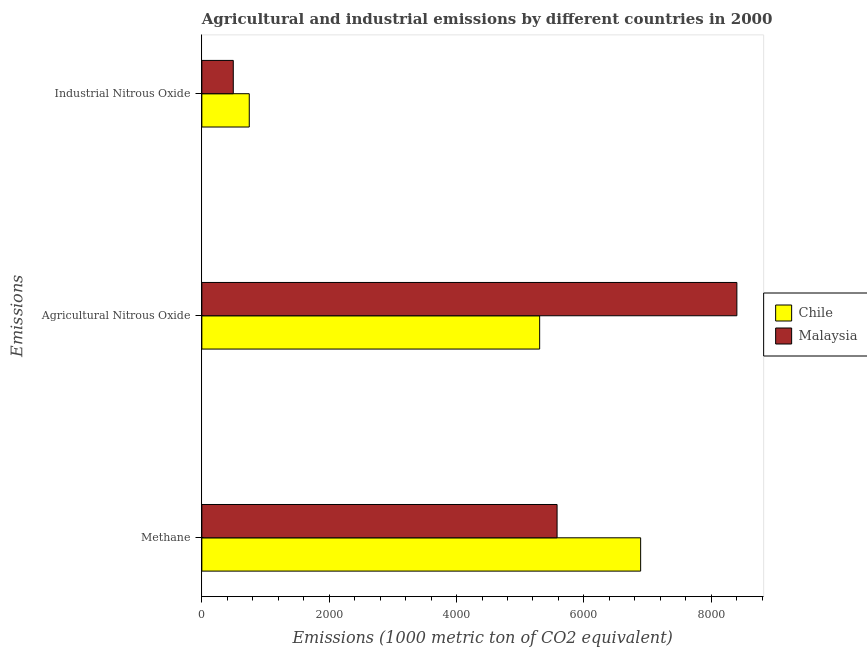How many different coloured bars are there?
Provide a short and direct response. 2. How many groups of bars are there?
Your answer should be compact. 3. How many bars are there on the 2nd tick from the bottom?
Offer a very short reply. 2. What is the label of the 3rd group of bars from the top?
Keep it short and to the point. Methane. What is the amount of methane emissions in Chile?
Your answer should be compact. 6891.6. Across all countries, what is the maximum amount of agricultural nitrous oxide emissions?
Your answer should be very brief. 8403.2. Across all countries, what is the minimum amount of industrial nitrous oxide emissions?
Offer a very short reply. 493.8. In which country was the amount of methane emissions minimum?
Offer a very short reply. Malaysia. What is the total amount of agricultural nitrous oxide emissions in the graph?
Give a very brief answer. 1.37e+04. What is the difference between the amount of methane emissions in Malaysia and that in Chile?
Your response must be concise. -1312.4. What is the difference between the amount of industrial nitrous oxide emissions in Malaysia and the amount of methane emissions in Chile?
Provide a succinct answer. -6397.8. What is the average amount of methane emissions per country?
Provide a short and direct response. 6235.4. What is the difference between the amount of methane emissions and amount of industrial nitrous oxide emissions in Malaysia?
Your answer should be compact. 5085.4. What is the ratio of the amount of industrial nitrous oxide emissions in Malaysia to that in Chile?
Give a very brief answer. 0.66. Is the amount of industrial nitrous oxide emissions in Malaysia less than that in Chile?
Offer a very short reply. Yes. What is the difference between the highest and the second highest amount of methane emissions?
Make the answer very short. 1312.4. What is the difference between the highest and the lowest amount of industrial nitrous oxide emissions?
Offer a very short reply. 251.1. What does the 1st bar from the top in Industrial Nitrous Oxide represents?
Offer a terse response. Malaysia. What does the 2nd bar from the bottom in Methane represents?
Provide a short and direct response. Malaysia. How many countries are there in the graph?
Make the answer very short. 2. What is the difference between two consecutive major ticks on the X-axis?
Your answer should be very brief. 2000. Does the graph contain any zero values?
Ensure brevity in your answer.  No. Where does the legend appear in the graph?
Your response must be concise. Center right. How many legend labels are there?
Ensure brevity in your answer.  2. What is the title of the graph?
Make the answer very short. Agricultural and industrial emissions by different countries in 2000. What is the label or title of the X-axis?
Make the answer very short. Emissions (1000 metric ton of CO2 equivalent). What is the label or title of the Y-axis?
Ensure brevity in your answer.  Emissions. What is the Emissions (1000 metric ton of CO2 equivalent) of Chile in Methane?
Your answer should be very brief. 6891.6. What is the Emissions (1000 metric ton of CO2 equivalent) of Malaysia in Methane?
Ensure brevity in your answer.  5579.2. What is the Emissions (1000 metric ton of CO2 equivalent) of Chile in Agricultural Nitrous Oxide?
Your answer should be very brief. 5305.7. What is the Emissions (1000 metric ton of CO2 equivalent) of Malaysia in Agricultural Nitrous Oxide?
Give a very brief answer. 8403.2. What is the Emissions (1000 metric ton of CO2 equivalent) in Chile in Industrial Nitrous Oxide?
Give a very brief answer. 744.9. What is the Emissions (1000 metric ton of CO2 equivalent) of Malaysia in Industrial Nitrous Oxide?
Keep it short and to the point. 493.8. Across all Emissions, what is the maximum Emissions (1000 metric ton of CO2 equivalent) in Chile?
Keep it short and to the point. 6891.6. Across all Emissions, what is the maximum Emissions (1000 metric ton of CO2 equivalent) in Malaysia?
Offer a terse response. 8403.2. Across all Emissions, what is the minimum Emissions (1000 metric ton of CO2 equivalent) of Chile?
Give a very brief answer. 744.9. Across all Emissions, what is the minimum Emissions (1000 metric ton of CO2 equivalent) in Malaysia?
Your response must be concise. 493.8. What is the total Emissions (1000 metric ton of CO2 equivalent) in Chile in the graph?
Give a very brief answer. 1.29e+04. What is the total Emissions (1000 metric ton of CO2 equivalent) of Malaysia in the graph?
Provide a succinct answer. 1.45e+04. What is the difference between the Emissions (1000 metric ton of CO2 equivalent) in Chile in Methane and that in Agricultural Nitrous Oxide?
Provide a succinct answer. 1585.9. What is the difference between the Emissions (1000 metric ton of CO2 equivalent) of Malaysia in Methane and that in Agricultural Nitrous Oxide?
Offer a very short reply. -2824. What is the difference between the Emissions (1000 metric ton of CO2 equivalent) in Chile in Methane and that in Industrial Nitrous Oxide?
Provide a short and direct response. 6146.7. What is the difference between the Emissions (1000 metric ton of CO2 equivalent) in Malaysia in Methane and that in Industrial Nitrous Oxide?
Your answer should be very brief. 5085.4. What is the difference between the Emissions (1000 metric ton of CO2 equivalent) of Chile in Agricultural Nitrous Oxide and that in Industrial Nitrous Oxide?
Offer a very short reply. 4560.8. What is the difference between the Emissions (1000 metric ton of CO2 equivalent) of Malaysia in Agricultural Nitrous Oxide and that in Industrial Nitrous Oxide?
Your answer should be compact. 7909.4. What is the difference between the Emissions (1000 metric ton of CO2 equivalent) of Chile in Methane and the Emissions (1000 metric ton of CO2 equivalent) of Malaysia in Agricultural Nitrous Oxide?
Ensure brevity in your answer.  -1511.6. What is the difference between the Emissions (1000 metric ton of CO2 equivalent) of Chile in Methane and the Emissions (1000 metric ton of CO2 equivalent) of Malaysia in Industrial Nitrous Oxide?
Your answer should be very brief. 6397.8. What is the difference between the Emissions (1000 metric ton of CO2 equivalent) in Chile in Agricultural Nitrous Oxide and the Emissions (1000 metric ton of CO2 equivalent) in Malaysia in Industrial Nitrous Oxide?
Keep it short and to the point. 4811.9. What is the average Emissions (1000 metric ton of CO2 equivalent) in Chile per Emissions?
Provide a succinct answer. 4314.07. What is the average Emissions (1000 metric ton of CO2 equivalent) in Malaysia per Emissions?
Keep it short and to the point. 4825.4. What is the difference between the Emissions (1000 metric ton of CO2 equivalent) in Chile and Emissions (1000 metric ton of CO2 equivalent) in Malaysia in Methane?
Your response must be concise. 1312.4. What is the difference between the Emissions (1000 metric ton of CO2 equivalent) in Chile and Emissions (1000 metric ton of CO2 equivalent) in Malaysia in Agricultural Nitrous Oxide?
Offer a very short reply. -3097.5. What is the difference between the Emissions (1000 metric ton of CO2 equivalent) of Chile and Emissions (1000 metric ton of CO2 equivalent) of Malaysia in Industrial Nitrous Oxide?
Ensure brevity in your answer.  251.1. What is the ratio of the Emissions (1000 metric ton of CO2 equivalent) in Chile in Methane to that in Agricultural Nitrous Oxide?
Make the answer very short. 1.3. What is the ratio of the Emissions (1000 metric ton of CO2 equivalent) of Malaysia in Methane to that in Agricultural Nitrous Oxide?
Provide a succinct answer. 0.66. What is the ratio of the Emissions (1000 metric ton of CO2 equivalent) in Chile in Methane to that in Industrial Nitrous Oxide?
Your answer should be very brief. 9.25. What is the ratio of the Emissions (1000 metric ton of CO2 equivalent) in Malaysia in Methane to that in Industrial Nitrous Oxide?
Keep it short and to the point. 11.3. What is the ratio of the Emissions (1000 metric ton of CO2 equivalent) of Chile in Agricultural Nitrous Oxide to that in Industrial Nitrous Oxide?
Ensure brevity in your answer.  7.12. What is the ratio of the Emissions (1000 metric ton of CO2 equivalent) of Malaysia in Agricultural Nitrous Oxide to that in Industrial Nitrous Oxide?
Your answer should be very brief. 17.02. What is the difference between the highest and the second highest Emissions (1000 metric ton of CO2 equivalent) of Chile?
Offer a very short reply. 1585.9. What is the difference between the highest and the second highest Emissions (1000 metric ton of CO2 equivalent) of Malaysia?
Offer a terse response. 2824. What is the difference between the highest and the lowest Emissions (1000 metric ton of CO2 equivalent) of Chile?
Provide a short and direct response. 6146.7. What is the difference between the highest and the lowest Emissions (1000 metric ton of CO2 equivalent) of Malaysia?
Ensure brevity in your answer.  7909.4. 